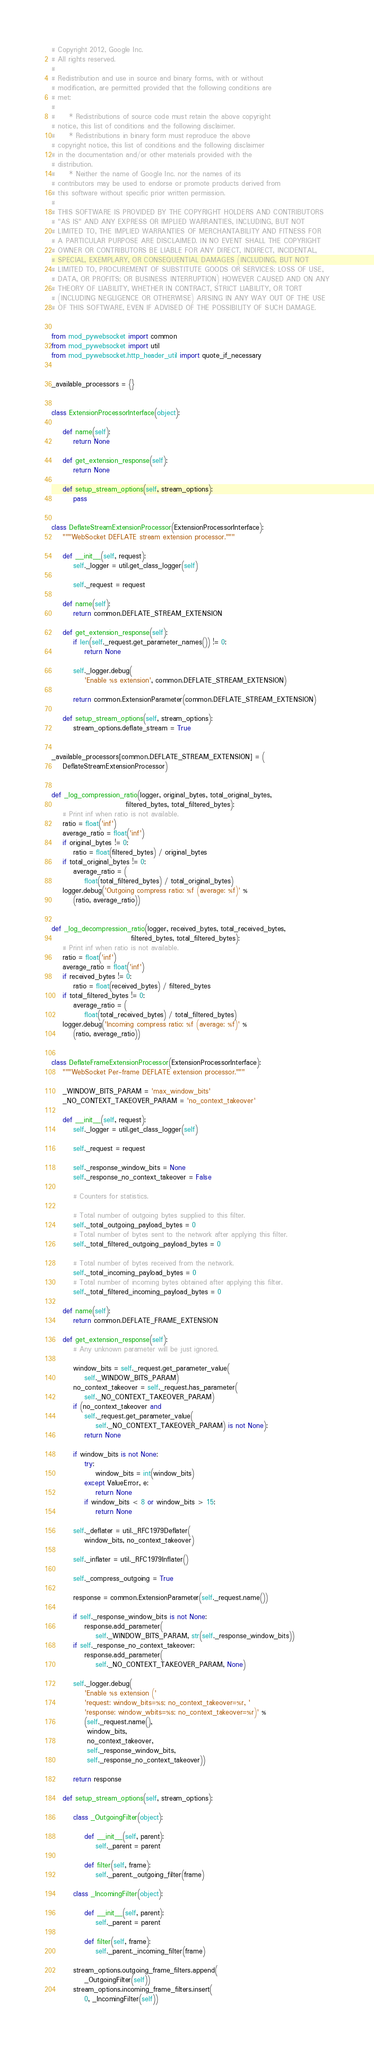<code> <loc_0><loc_0><loc_500><loc_500><_Python_># Copyright 2012, Google Inc.
# All rights reserved.
#
# Redistribution and use in source and binary forms, with or without
# modification, are permitted provided that the following conditions are
# met:
#
#     * Redistributions of source code must retain the above copyright
# notice, this list of conditions and the following disclaimer.
#     * Redistributions in binary form must reproduce the above
# copyright notice, this list of conditions and the following disclaimer
# in the documentation and/or other materials provided with the
# distribution.
#     * Neither the name of Google Inc. nor the names of its
# contributors may be used to endorse or promote products derived from
# this software without specific prior written permission.
#
# THIS SOFTWARE IS PROVIDED BY THE COPYRIGHT HOLDERS AND CONTRIBUTORS
# "AS IS" AND ANY EXPRESS OR IMPLIED WARRANTIES, INCLUDING, BUT NOT
# LIMITED TO, THE IMPLIED WARRANTIES OF MERCHANTABILITY AND FITNESS FOR
# A PARTICULAR PURPOSE ARE DISCLAIMED. IN NO EVENT SHALL THE COPYRIGHT
# OWNER OR CONTRIBUTORS BE LIABLE FOR ANY DIRECT, INDIRECT, INCIDENTAL,
# SPECIAL, EXEMPLARY, OR CONSEQUENTIAL DAMAGES (INCLUDING, BUT NOT
# LIMITED TO, PROCUREMENT OF SUBSTITUTE GOODS OR SERVICES; LOSS OF USE,
# DATA, OR PROFITS; OR BUSINESS INTERRUPTION) HOWEVER CAUSED AND ON ANY
# THEORY OF LIABILITY, WHETHER IN CONTRACT, STRICT LIABILITY, OR TORT
# (INCLUDING NEGLIGENCE OR OTHERWISE) ARISING IN ANY WAY OUT OF THE USE
# OF THIS SOFTWARE, EVEN IF ADVISED OF THE POSSIBILITY OF SUCH DAMAGE.


from mod_pywebsocket import common
from mod_pywebsocket import util
from mod_pywebsocket.http_header_util import quote_if_necessary


_available_processors = {}


class ExtensionProcessorInterface(object):

    def name(self):
        return None

    def get_extension_response(self):
        return None

    def setup_stream_options(self, stream_options):
        pass


class DeflateStreamExtensionProcessor(ExtensionProcessorInterface):
    """WebSocket DEFLATE stream extension processor."""

    def __init__(self, request):
        self._logger = util.get_class_logger(self)

        self._request = request

    def name(self):
        return common.DEFLATE_STREAM_EXTENSION

    def get_extension_response(self):
        if len(self._request.get_parameter_names()) != 0:
            return None

        self._logger.debug(
            'Enable %s extension', common.DEFLATE_STREAM_EXTENSION)

        return common.ExtensionParameter(common.DEFLATE_STREAM_EXTENSION)

    def setup_stream_options(self, stream_options):
        stream_options.deflate_stream = True


_available_processors[common.DEFLATE_STREAM_EXTENSION] = (
    DeflateStreamExtensionProcessor)


def _log_compression_ratio(logger, original_bytes, total_original_bytes,
                           filtered_bytes, total_filtered_bytes):
    # Print inf when ratio is not available.
    ratio = float('inf')
    average_ratio = float('inf')
    if original_bytes != 0:
        ratio = float(filtered_bytes) / original_bytes
    if total_original_bytes != 0:
        average_ratio = (
            float(total_filtered_bytes) / total_original_bytes)
    logger.debug('Outgoing compress ratio: %f (average: %f)' %
        (ratio, average_ratio))


def _log_decompression_ratio(logger, received_bytes, total_received_bytes,
                             filtered_bytes, total_filtered_bytes):
    # Print inf when ratio is not available.
    ratio = float('inf')
    average_ratio = float('inf')
    if received_bytes != 0:
        ratio = float(received_bytes) / filtered_bytes
    if total_filtered_bytes != 0:
        average_ratio = (
            float(total_received_bytes) / total_filtered_bytes)
    logger.debug('Incoming compress ratio: %f (average: %f)' %
        (ratio, average_ratio))


class DeflateFrameExtensionProcessor(ExtensionProcessorInterface):
    """WebSocket Per-frame DEFLATE extension processor."""

    _WINDOW_BITS_PARAM = 'max_window_bits'
    _NO_CONTEXT_TAKEOVER_PARAM = 'no_context_takeover'

    def __init__(self, request):
        self._logger = util.get_class_logger(self)

        self._request = request

        self._response_window_bits = None
        self._response_no_context_takeover = False

        # Counters for statistics.

        # Total number of outgoing bytes supplied to this filter.
        self._total_outgoing_payload_bytes = 0
        # Total number of bytes sent to the network after applying this filter.
        self._total_filtered_outgoing_payload_bytes = 0

        # Total number of bytes received from the network.
        self._total_incoming_payload_bytes = 0
        # Total number of incoming bytes obtained after applying this filter.
        self._total_filtered_incoming_payload_bytes = 0

    def name(self):
        return common.DEFLATE_FRAME_EXTENSION

    def get_extension_response(self):
        # Any unknown parameter will be just ignored.

        window_bits = self._request.get_parameter_value(
            self._WINDOW_BITS_PARAM)
        no_context_takeover = self._request.has_parameter(
            self._NO_CONTEXT_TAKEOVER_PARAM)
        if (no_context_takeover and
            self._request.get_parameter_value(
                self._NO_CONTEXT_TAKEOVER_PARAM) is not None):
            return None

        if window_bits is not None:
            try:
                window_bits = int(window_bits)
            except ValueError, e:
                return None
            if window_bits < 8 or window_bits > 15:
                return None

        self._deflater = util._RFC1979Deflater(
            window_bits, no_context_takeover)

        self._inflater = util._RFC1979Inflater()

        self._compress_outgoing = True

        response = common.ExtensionParameter(self._request.name())

        if self._response_window_bits is not None:
            response.add_parameter(
                self._WINDOW_BITS_PARAM, str(self._response_window_bits))
        if self._response_no_context_takeover:
            response.add_parameter(
                self._NO_CONTEXT_TAKEOVER_PARAM, None)

        self._logger.debug(
            'Enable %s extension ('
            'request: window_bits=%s; no_context_takeover=%r, '
            'response: window_wbits=%s; no_context_takeover=%r)' %
            (self._request.name(),
             window_bits,
             no_context_takeover,
             self._response_window_bits,
             self._response_no_context_takeover))

        return response

    def setup_stream_options(self, stream_options):

        class _OutgoingFilter(object):

            def __init__(self, parent):
                self._parent = parent

            def filter(self, frame):
                self._parent._outgoing_filter(frame)

        class _IncomingFilter(object):

            def __init__(self, parent):
                self._parent = parent

            def filter(self, frame):
                self._parent._incoming_filter(frame)

        stream_options.outgoing_frame_filters.append(
            _OutgoingFilter(self))
        stream_options.incoming_frame_filters.insert(
            0, _IncomingFilter(self))
</code> 